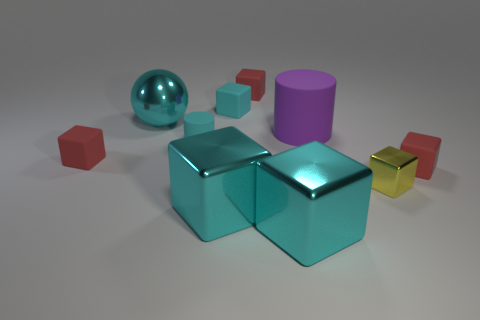Subtract all green spheres. How many cyan blocks are left? 3 Subtract 4 cubes. How many cubes are left? 3 Subtract all yellow blocks. How many blocks are left? 6 Subtract all yellow cubes. How many cubes are left? 6 Subtract all yellow cubes. Subtract all purple spheres. How many cubes are left? 6 Subtract all spheres. How many objects are left? 9 Add 2 purple matte cylinders. How many purple matte cylinders exist? 3 Subtract 0 green balls. How many objects are left? 10 Subtract all small cyan matte cubes. Subtract all purple matte things. How many objects are left? 8 Add 1 small matte things. How many small matte things are left? 6 